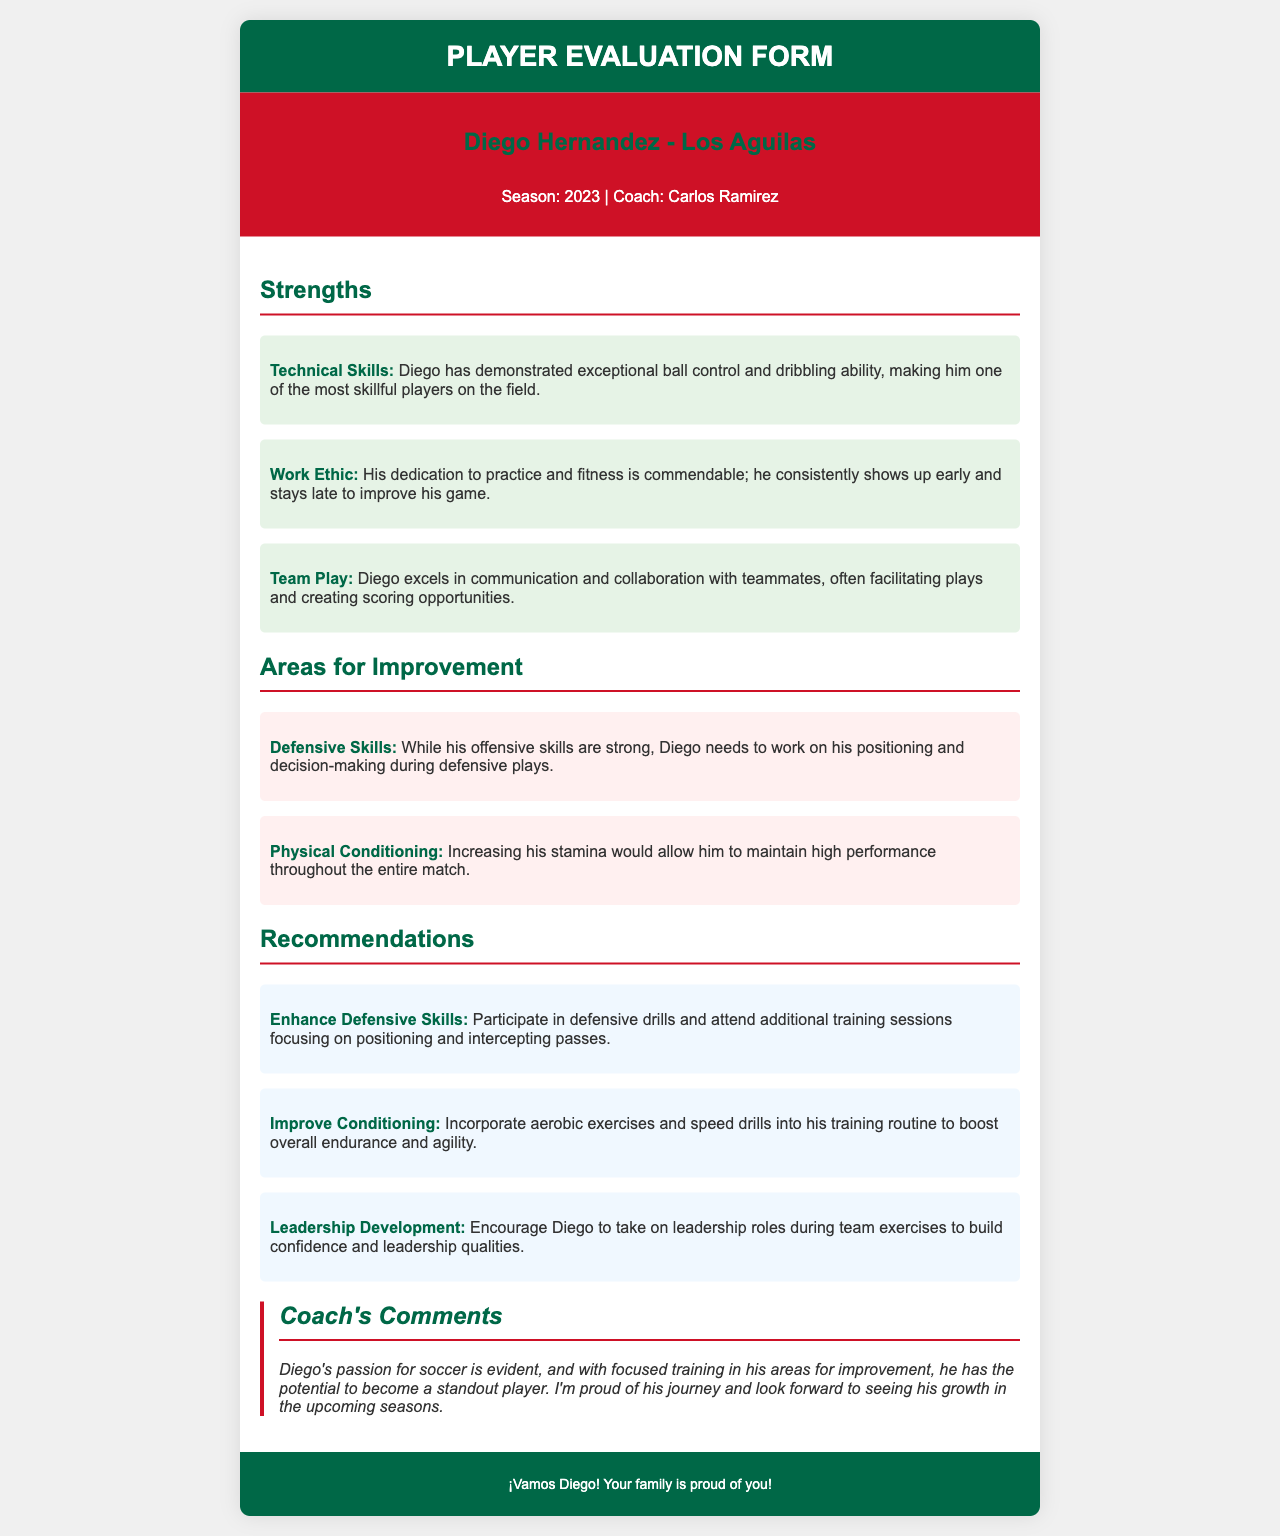What is the player's name? The player's name is mentioned in the title of the evaluation form.
Answer: Diego Hernandez Who is the coach? The coach's name is listed under the player's information.
Answer: Carlos Ramirez What season is being evaluated? The season is presented in the player information section.
Answer: 2023 What is one of Diego's technical skills? A specific strength regarding technical skills is mentioned in the strengths section.
Answer: Exceptional ball control What area does Diego need to improve? The areas for improvement section identifies specific skills needing development.
Answer: Defensive Skills What is a recommended way to enhance Diego's defensive skills? Recommendations section provides specific actions for improvement.
Answer: Participate in defensive drills What does the coach say about Diego's passion for soccer? The coach's comments provide insights into Diego's attitude towards the sport.
Answer: Evident What is one way to improve Diego's physical conditioning? The recommendations section suggests methods to enhance overall fitness.
Answer: Incorporate aerobic exercises What is stated about Diego's work ethic? The strengths section mentions Diego's dedication to practice and fitness.
Answer: Commendable 